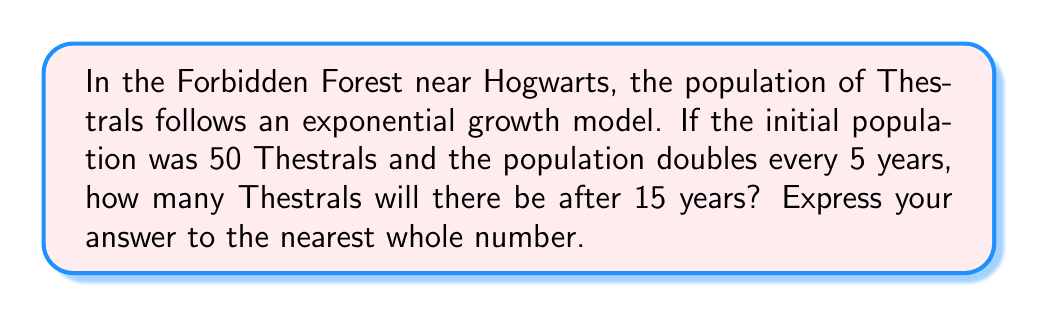Give your solution to this math problem. Let's approach this step-by-step:

1) The exponential growth model is given by the formula:
   $$P(t) = P_0 \cdot e^{rt}$$
   Where:
   $P(t)$ is the population at time $t$
   $P_0$ is the initial population
   $r$ is the growth rate
   $t$ is the time elapsed

2) We're given that $P_0 = 50$ and the population doubles every 5 years.

3) To find $r$, we can use the doubling time formula:
   $$2 = e^{5r}$$
   Taking the natural log of both sides:
   $$\ln(2) = 5r$$
   $$r = \frac{\ln(2)}{5} \approx 0.1386$$

4) Now we can plug everything into our formula:
   $$P(15) = 50 \cdot e^{0.1386 \cdot 15}$$

5) Calculating this:
   $$P(15) = 50 \cdot e^{2.079} \approx 50 \cdot 7.996 \approx 399.8$$

6) Rounding to the nearest whole number, we get 400.
Answer: 400 Thestrals 